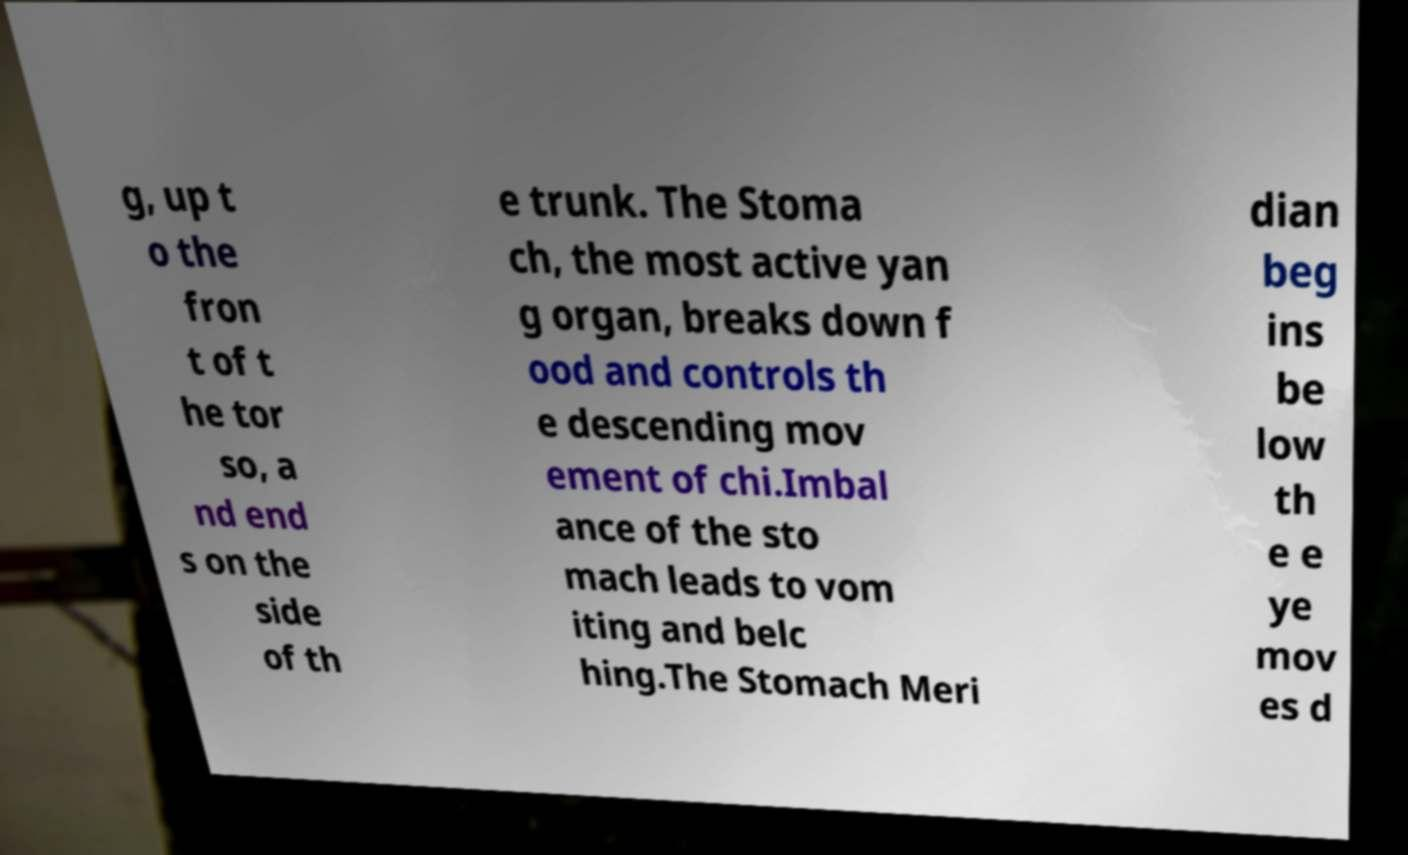Can you accurately transcribe the text from the provided image for me? g, up t o the fron t of t he tor so, a nd end s on the side of th e trunk. The Stoma ch, the most active yan g organ, breaks down f ood and controls th e descending mov ement of chi.Imbal ance of the sto mach leads to vom iting and belc hing.The Stomach Meri dian beg ins be low th e e ye mov es d 